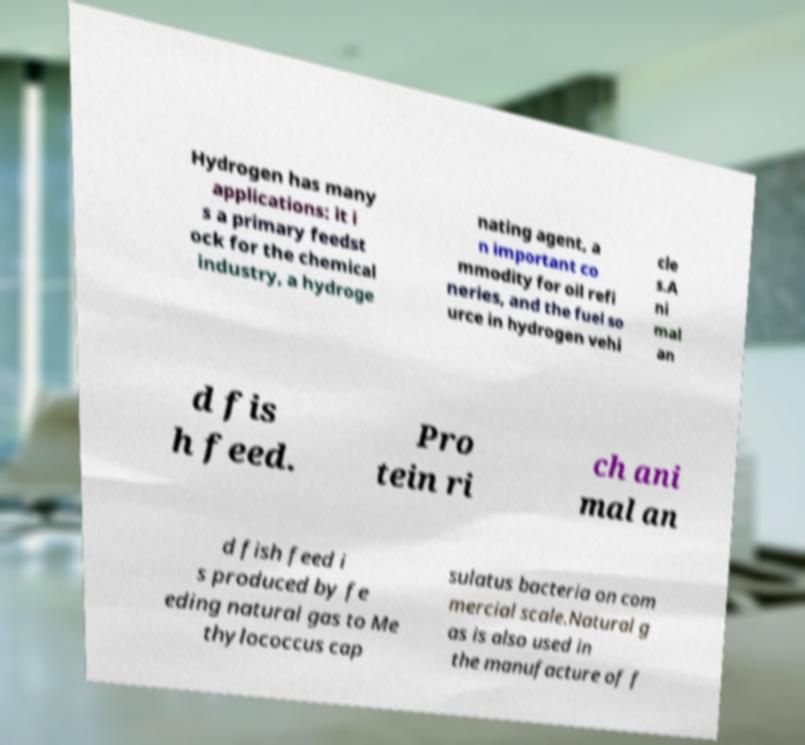I need the written content from this picture converted into text. Can you do that? Hydrogen has many applications: it i s a primary feedst ock for the chemical industry, a hydroge nating agent, a n important co mmodity for oil refi neries, and the fuel so urce in hydrogen vehi cle s.A ni mal an d fis h feed. Pro tein ri ch ani mal an d fish feed i s produced by fe eding natural gas to Me thylococcus cap sulatus bacteria on com mercial scale.Natural g as is also used in the manufacture of f 